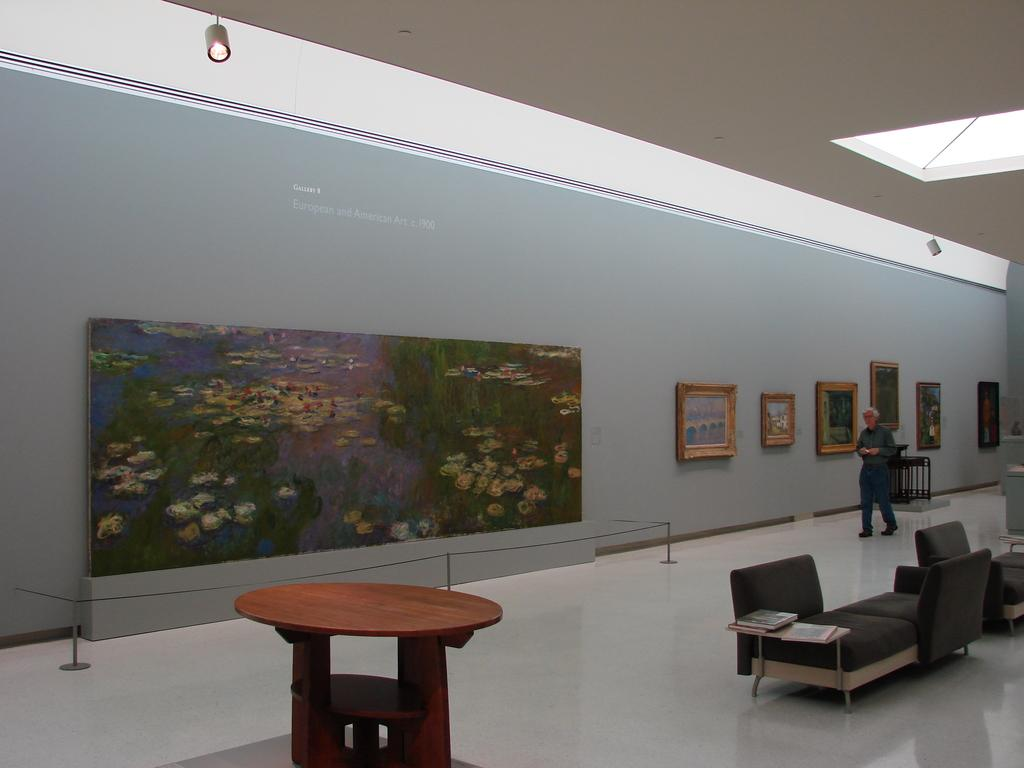Who is the main subject in the image? There is an old man in the image. What is the old man doing in the image? The old man is passing by paintings in the image. Where are the paintings located? The paintings are in a gallery. What type of sock is the old man wearing in the image? There is no information about the old man's socks in the image, so we cannot determine what type of sock he is wearing. 